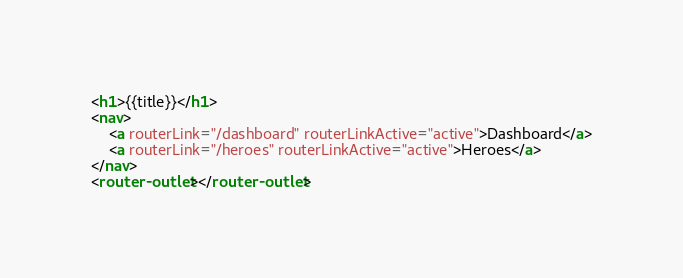Convert code to text. <code><loc_0><loc_0><loc_500><loc_500><_HTML_><h1>{{title}}</h1>
<nav>
	<a routerLink="/dashboard" routerLinkActive="active">Dashboard</a>
	<a routerLink="/heroes" routerLinkActive="active">Heroes</a>
</nav>
<router-outlet></router-outlet></code> 